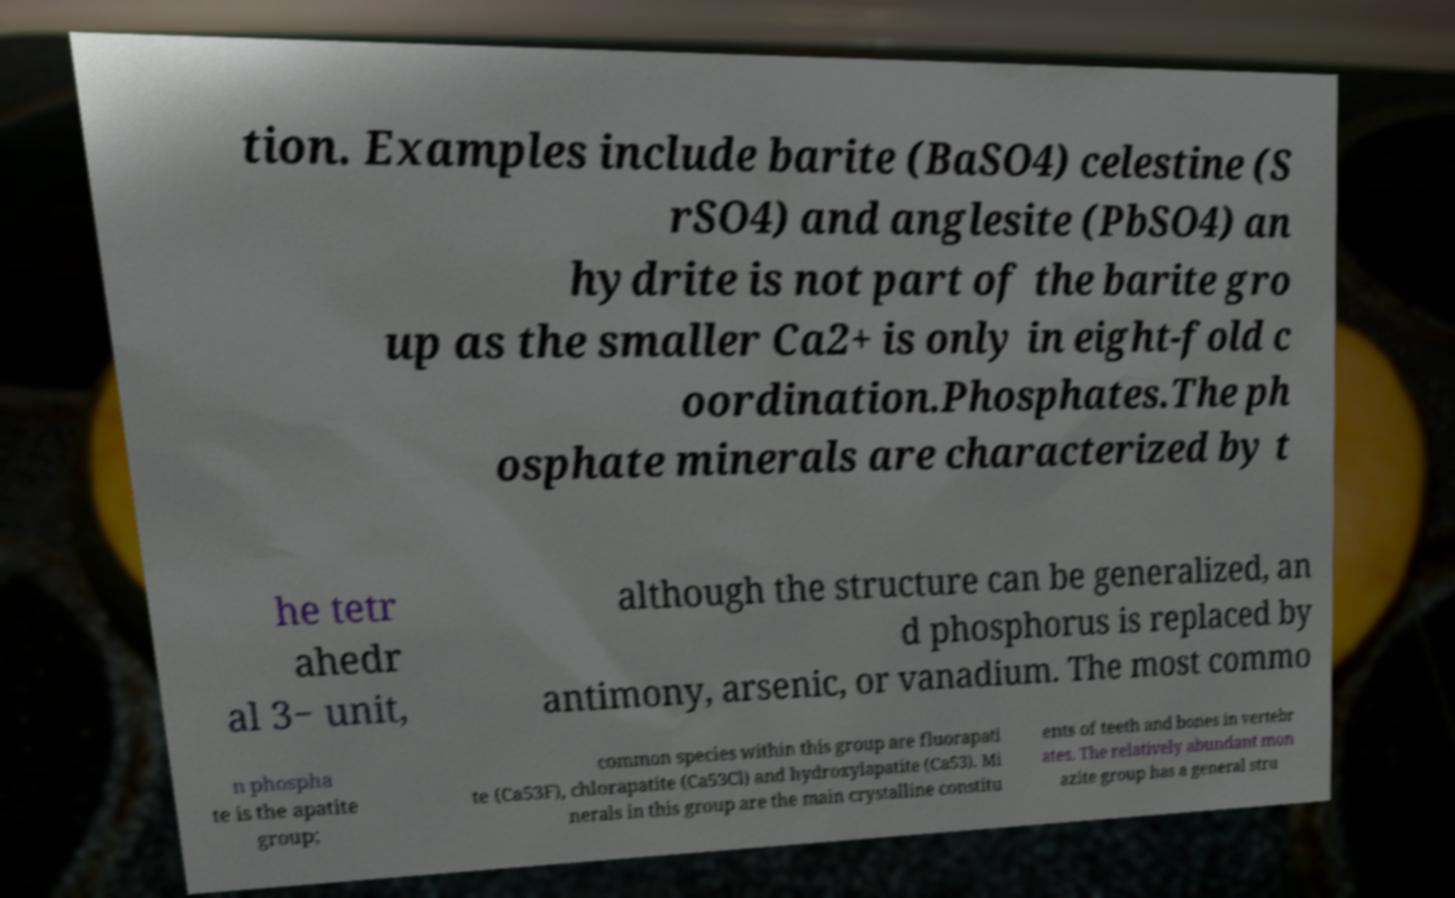Please identify and transcribe the text found in this image. tion. Examples include barite (BaSO4) celestine (S rSO4) and anglesite (PbSO4) an hydrite is not part of the barite gro up as the smaller Ca2+ is only in eight-fold c oordination.Phosphates.The ph osphate minerals are characterized by t he tetr ahedr al 3− unit, although the structure can be generalized, an d phosphorus is replaced by antimony, arsenic, or vanadium. The most commo n phospha te is the apatite group; common species within this group are fluorapati te (Ca53F), chlorapatite (Ca53Cl) and hydroxylapatite (Ca53). Mi nerals in this group are the main crystalline constitu ents of teeth and bones in vertebr ates. The relatively abundant mon azite group has a general stru 